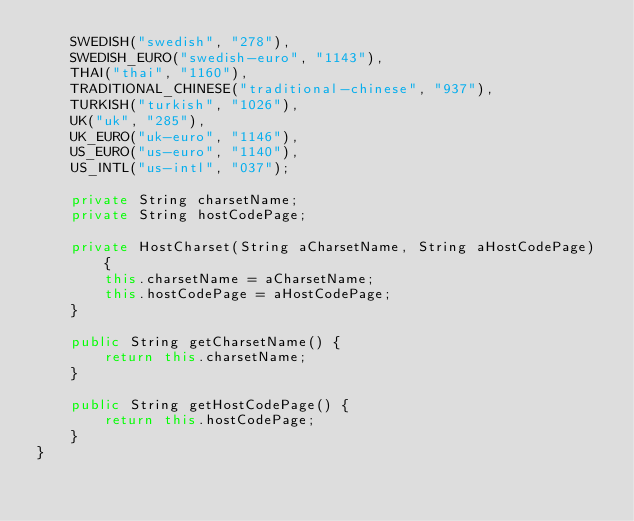Convert code to text. <code><loc_0><loc_0><loc_500><loc_500><_Java_>	SWEDISH("swedish", "278"),
	SWEDISH_EURO("swedish-euro", "1143"),
	THAI("thai", "1160"),
	TRADITIONAL_CHINESE("traditional-chinese", "937"),
	TURKISH("turkish", "1026"),
	UK("uk", "285"),
	UK_EURO("uk-euro", "1146"),
	US_EURO("us-euro", "1140"),
	US_INTL("us-intl", "037");

	private String charsetName;
	private String hostCodePage;
	
	private HostCharset(String aCharsetName, String aHostCodePage) {
		this.charsetName = aCharsetName;
		this.hostCodePage = aHostCodePage;
	}
	
	public String getCharsetName() {
		return this.charsetName;
	}
	
	public String getHostCodePage() {
		return this.hostCodePage;
	}
}
</code> 